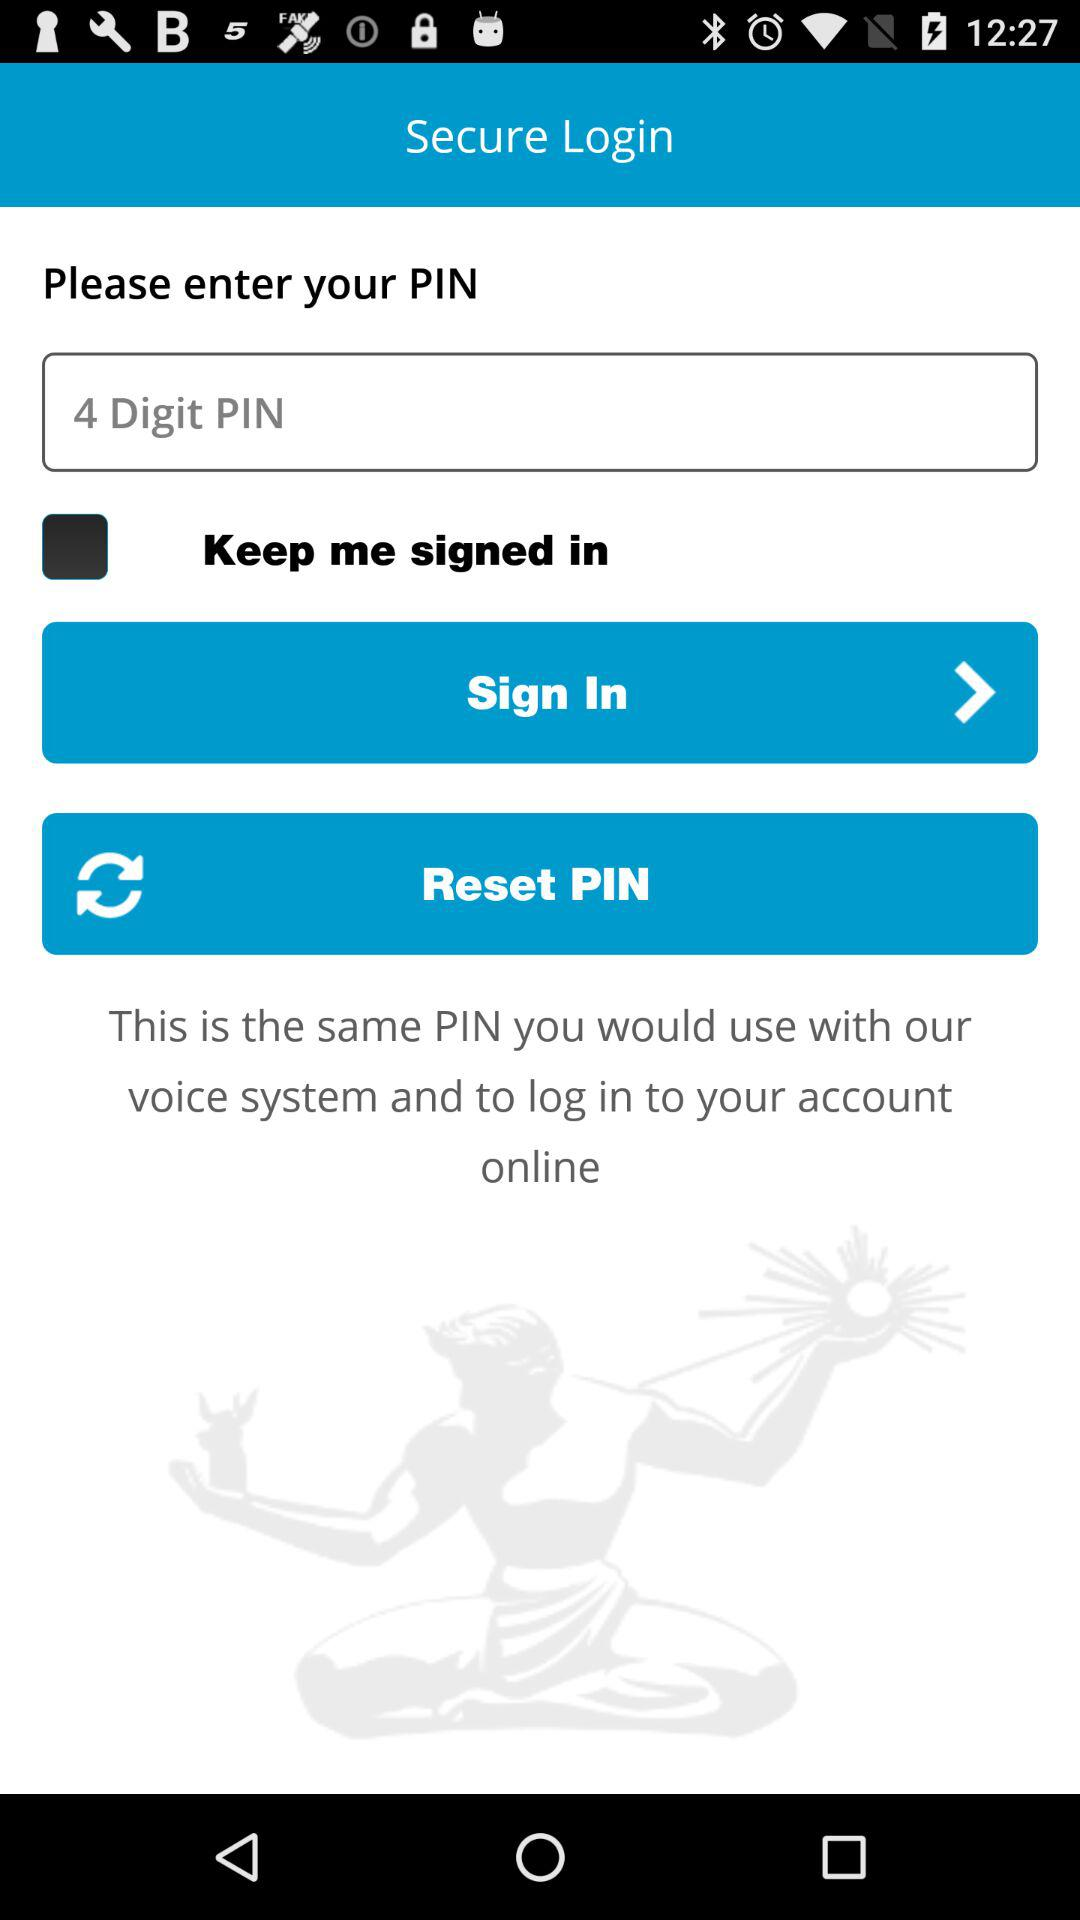How many digit pins are needed? The number of digit pins needed is 4. 